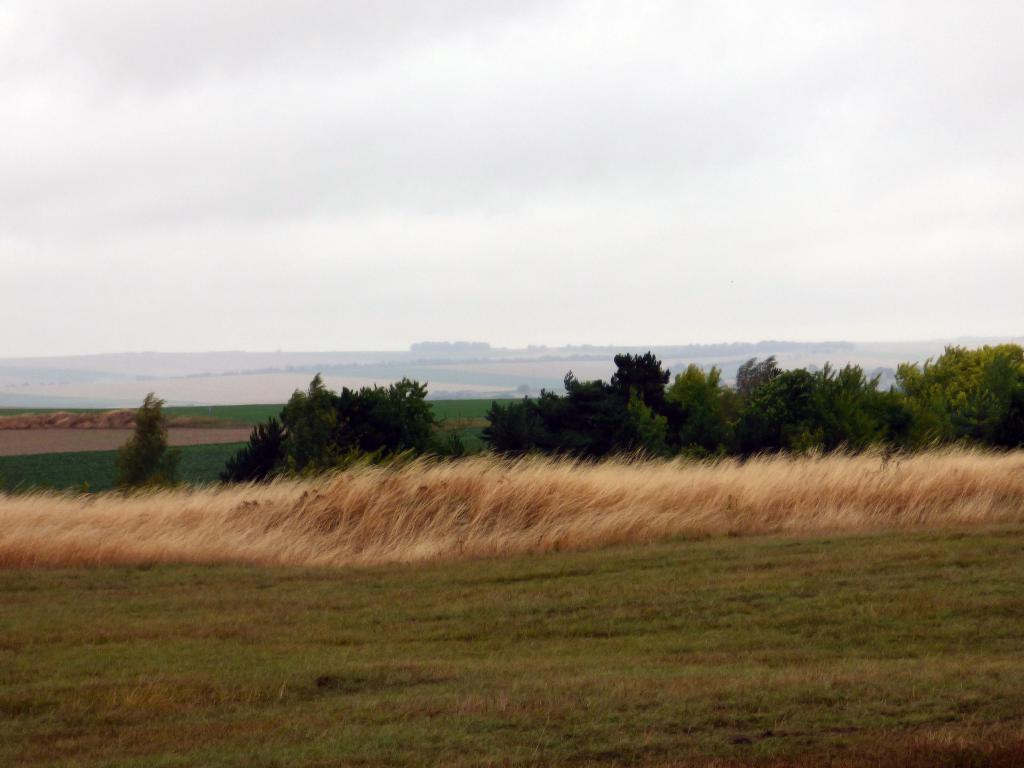What type of vegetation can be seen in the image? There is grass in the image. Are there any other plants visible in the image? Yes, there are trees in the image. What can be seen in the background of the image? The sky is visible in the background of the image. What type of wood is used to construct the wheel in the image? There is no wheel present in the image, so it is not possible to determine the type of wood used for its construction. 